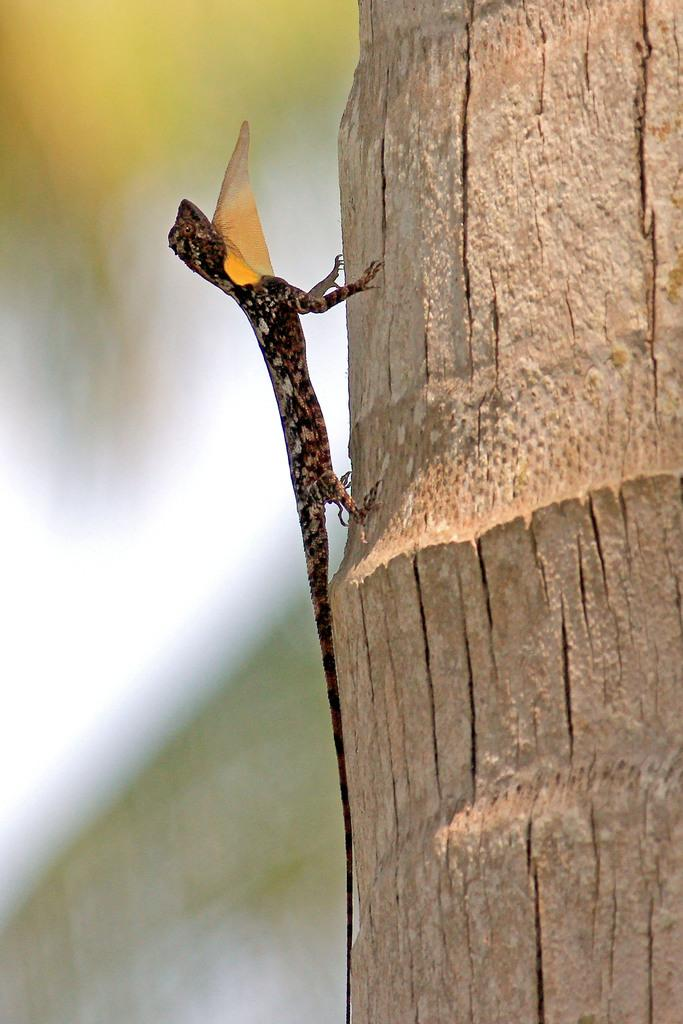What is the main subject of the image? There is a garden lizard in the center of the image. What can be seen on the right side of the image? There is a tree on the right side of the image. What type of brass instrument is being played by the garden lizard in the image? There is no brass instrument or any indication of music in the image; it features a garden lizard and a tree. 